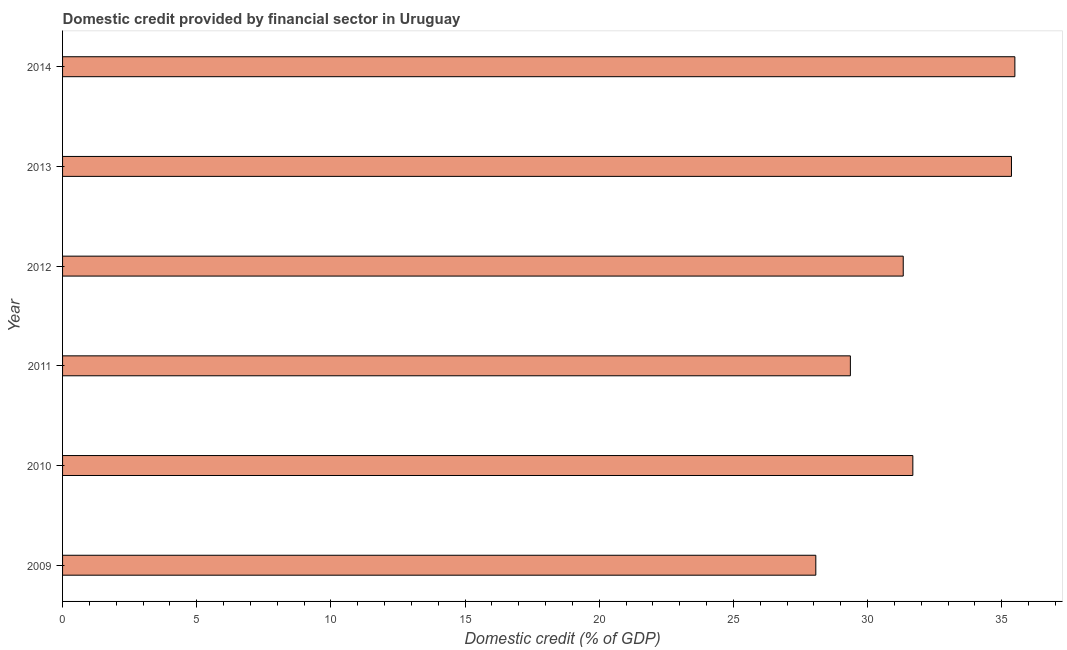Does the graph contain grids?
Offer a very short reply. No. What is the title of the graph?
Provide a short and direct response. Domestic credit provided by financial sector in Uruguay. What is the label or title of the X-axis?
Your response must be concise. Domestic credit (% of GDP). What is the domestic credit provided by financial sector in 2010?
Provide a short and direct response. 31.69. Across all years, what is the maximum domestic credit provided by financial sector?
Provide a short and direct response. 35.49. Across all years, what is the minimum domestic credit provided by financial sector?
Your answer should be very brief. 28.07. In which year was the domestic credit provided by financial sector maximum?
Keep it short and to the point. 2014. What is the sum of the domestic credit provided by financial sector?
Your answer should be compact. 191.31. What is the difference between the domestic credit provided by financial sector in 2010 and 2014?
Offer a very short reply. -3.8. What is the average domestic credit provided by financial sector per year?
Offer a very short reply. 31.88. What is the median domestic credit provided by financial sector?
Provide a short and direct response. 31.51. In how many years, is the domestic credit provided by financial sector greater than 30 %?
Your response must be concise. 4. Do a majority of the years between 2011 and 2012 (inclusive) have domestic credit provided by financial sector greater than 13 %?
Your answer should be very brief. Yes. Is the domestic credit provided by financial sector in 2012 less than that in 2014?
Ensure brevity in your answer.  Yes. What is the difference between the highest and the second highest domestic credit provided by financial sector?
Your answer should be very brief. 0.13. What is the difference between the highest and the lowest domestic credit provided by financial sector?
Your answer should be very brief. 7.42. In how many years, is the domestic credit provided by financial sector greater than the average domestic credit provided by financial sector taken over all years?
Your answer should be compact. 2. Are the values on the major ticks of X-axis written in scientific E-notation?
Your answer should be compact. No. What is the Domestic credit (% of GDP) of 2009?
Your answer should be compact. 28.07. What is the Domestic credit (% of GDP) in 2010?
Give a very brief answer. 31.69. What is the Domestic credit (% of GDP) of 2011?
Keep it short and to the point. 29.36. What is the Domestic credit (% of GDP) of 2012?
Offer a very short reply. 31.33. What is the Domestic credit (% of GDP) of 2013?
Keep it short and to the point. 35.36. What is the Domestic credit (% of GDP) in 2014?
Your response must be concise. 35.49. What is the difference between the Domestic credit (% of GDP) in 2009 and 2010?
Make the answer very short. -3.62. What is the difference between the Domestic credit (% of GDP) in 2009 and 2011?
Offer a very short reply. -1.29. What is the difference between the Domestic credit (% of GDP) in 2009 and 2012?
Your response must be concise. -3.26. What is the difference between the Domestic credit (% of GDP) in 2009 and 2013?
Make the answer very short. -7.29. What is the difference between the Domestic credit (% of GDP) in 2009 and 2014?
Your answer should be very brief. -7.42. What is the difference between the Domestic credit (% of GDP) in 2010 and 2011?
Offer a very short reply. 2.33. What is the difference between the Domestic credit (% of GDP) in 2010 and 2012?
Ensure brevity in your answer.  0.36. What is the difference between the Domestic credit (% of GDP) in 2010 and 2013?
Provide a short and direct response. -3.68. What is the difference between the Domestic credit (% of GDP) in 2010 and 2014?
Provide a succinct answer. -3.8. What is the difference between the Domestic credit (% of GDP) in 2011 and 2012?
Give a very brief answer. -1.97. What is the difference between the Domestic credit (% of GDP) in 2011 and 2013?
Provide a succinct answer. -6. What is the difference between the Domestic credit (% of GDP) in 2011 and 2014?
Make the answer very short. -6.13. What is the difference between the Domestic credit (% of GDP) in 2012 and 2013?
Give a very brief answer. -4.03. What is the difference between the Domestic credit (% of GDP) in 2012 and 2014?
Keep it short and to the point. -4.16. What is the difference between the Domestic credit (% of GDP) in 2013 and 2014?
Provide a succinct answer. -0.13. What is the ratio of the Domestic credit (% of GDP) in 2009 to that in 2010?
Give a very brief answer. 0.89. What is the ratio of the Domestic credit (% of GDP) in 2009 to that in 2011?
Ensure brevity in your answer.  0.96. What is the ratio of the Domestic credit (% of GDP) in 2009 to that in 2012?
Keep it short and to the point. 0.9. What is the ratio of the Domestic credit (% of GDP) in 2009 to that in 2013?
Keep it short and to the point. 0.79. What is the ratio of the Domestic credit (% of GDP) in 2009 to that in 2014?
Keep it short and to the point. 0.79. What is the ratio of the Domestic credit (% of GDP) in 2010 to that in 2011?
Your answer should be very brief. 1.08. What is the ratio of the Domestic credit (% of GDP) in 2010 to that in 2013?
Your answer should be very brief. 0.9. What is the ratio of the Domestic credit (% of GDP) in 2010 to that in 2014?
Provide a succinct answer. 0.89. What is the ratio of the Domestic credit (% of GDP) in 2011 to that in 2012?
Your response must be concise. 0.94. What is the ratio of the Domestic credit (% of GDP) in 2011 to that in 2013?
Give a very brief answer. 0.83. What is the ratio of the Domestic credit (% of GDP) in 2011 to that in 2014?
Your answer should be compact. 0.83. What is the ratio of the Domestic credit (% of GDP) in 2012 to that in 2013?
Ensure brevity in your answer.  0.89. What is the ratio of the Domestic credit (% of GDP) in 2012 to that in 2014?
Offer a very short reply. 0.88. What is the ratio of the Domestic credit (% of GDP) in 2013 to that in 2014?
Provide a succinct answer. 1. 